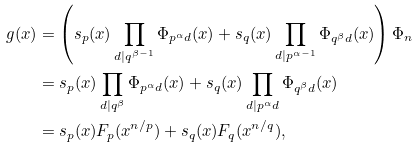Convert formula to latex. <formula><loc_0><loc_0><loc_500><loc_500>g ( x ) & = \left ( s _ { p } ( x ) \prod _ { d | q ^ { \beta - 1 } } \Phi _ { p ^ { \alpha } d } ( x ) + s _ { q } ( x ) \prod _ { d | p ^ { \alpha - 1 } } \Phi _ { q ^ { \beta } d } ( x ) \right ) \Phi _ { n } \\ & = s _ { p } ( x ) \prod _ { d | q ^ { \beta } } \Phi _ { p ^ { \alpha } d } ( x ) + s _ { q } ( x ) \prod _ { d | p ^ { \alpha } d } \Phi _ { q ^ { \beta } d } ( x ) \\ & = s _ { p } ( x ) F _ { p } ( x ^ { n / p } ) + s _ { q } ( x ) F _ { q } ( x ^ { n / q } ) ,</formula> 